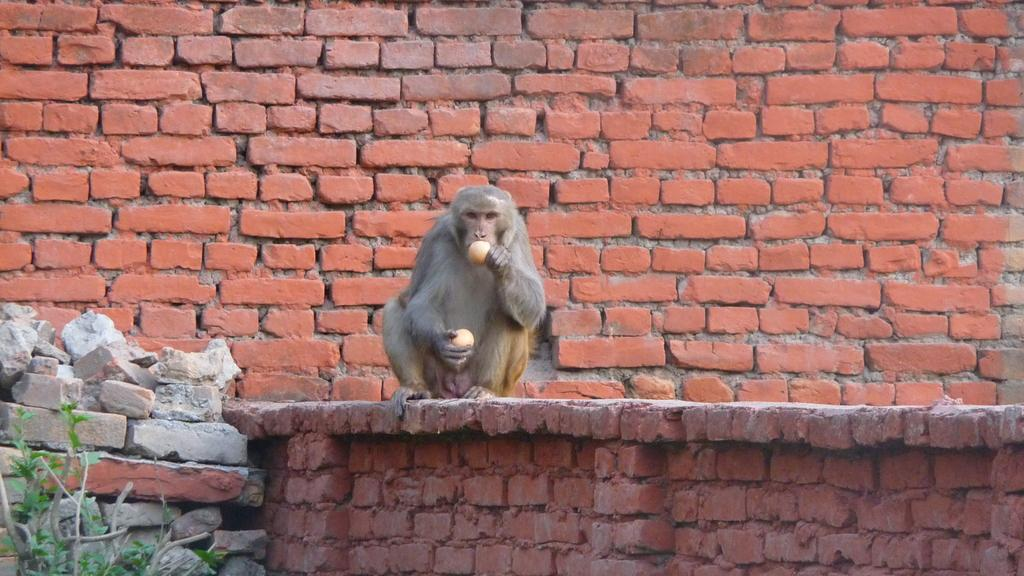What animal is present in the image? There is a monkey in the image. What is the monkey doing in the image? The monkey is sitting on a wall. What is the monkey holding in the image? The monkey is holding two fruits. What type of structure can be seen in the background of the image? There is a brick wall in the background of the image. What type of vegetation is present in the image? There is a plant on the left side bottom of the image. What type of thunder can be heard in the image? There is no sound present in the image, so it is not possible to hear any thunder. 